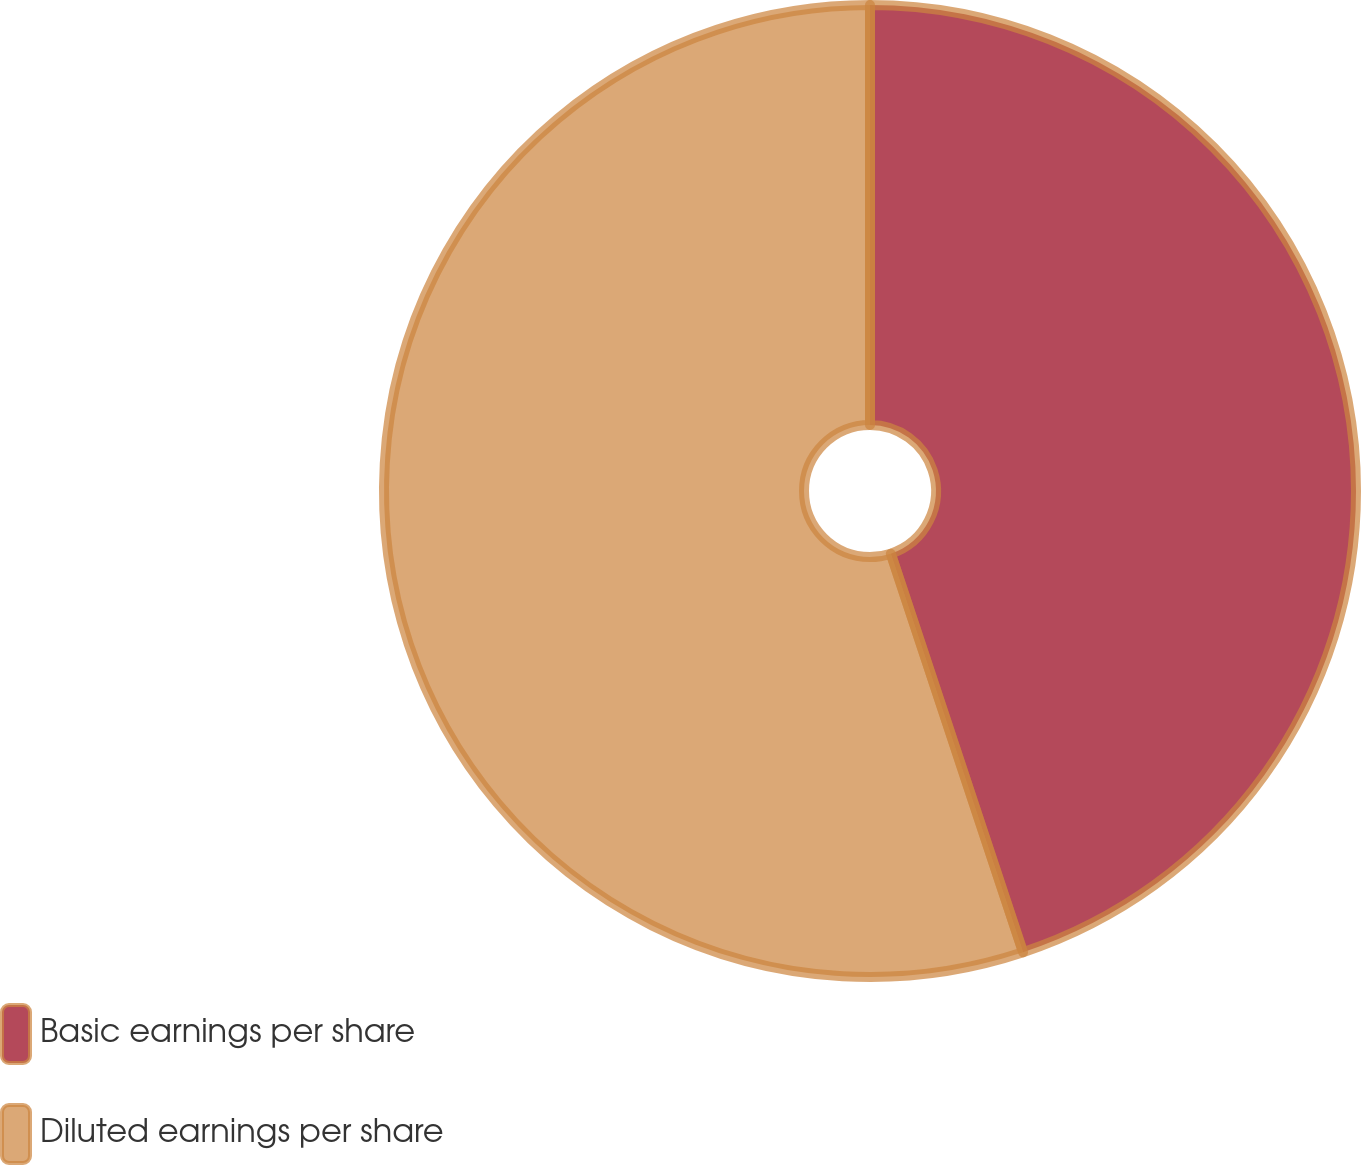Convert chart to OTSL. <chart><loc_0><loc_0><loc_500><loc_500><pie_chart><fcel>Basic earnings per share<fcel>Diluted earnings per share<nl><fcel>44.9%<fcel>55.1%<nl></chart> 